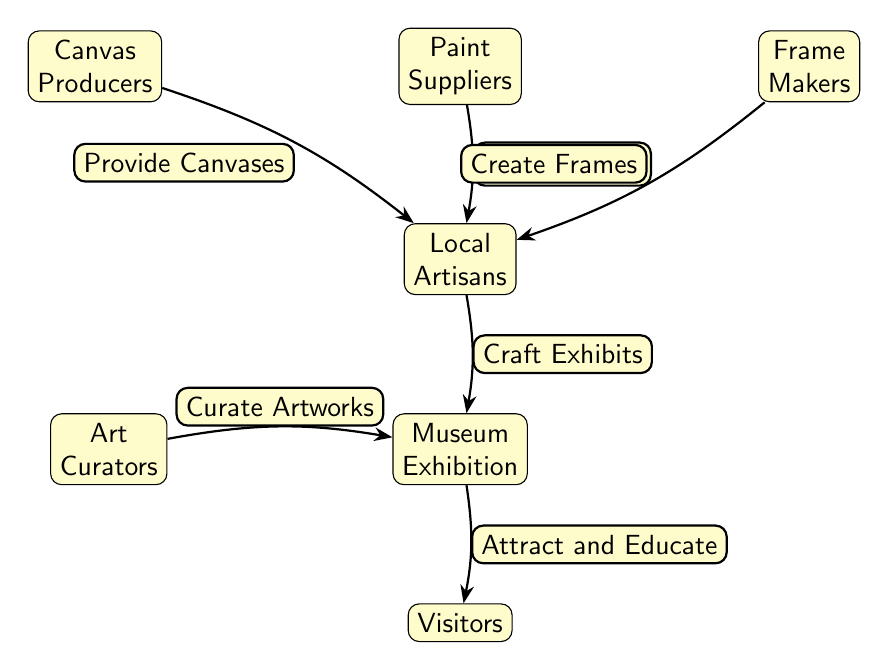What is the first node in the diagram? The first node in the diagram is labeled "Canvas Producers". It is positioned at the top-left corner of the diagram, signifying it as the starting element in the food chain.
Answer: Canvas Producers How many nodes are present in the diagram? There are a total of six nodes in the diagram: Canvas Producers, Paint Suppliers, Frame Makers, Local Artisans, Art Curators, Museum Exhibition, and Visitors. Counting these gives us a total of six distinct nodes.
Answer: 6 What does the Local Artisans node receive from the Paint Suppliers node? The Local Artisans node receives "Supply Paints" from the Paint Suppliers node. This is indicated by the directed edge between the two nodes showing the flow of supplies to the artisans.
Answer: Supply Paints Which node is directly below the Local Artisans node? The node directly below the Local Artisans node is labeled "Museum Exhibition." This is determined by looking at the vertical arrangement of the nodes in the diagram.
Answer: Museum Exhibition What relationships do the Art Curators have with the Museum Exhibition? The Art Curators are connected to the Museum Exhibition with the relationship "Curate Artworks." This indicates their role in organizing and selecting artworks for the exhibition.
Answer: Curate Artworks Which node attracts and educates the Visitors? The Museum Exhibition node attracts and educates the Visitors. This relationship is indicated by the edge leading from the exhibition to the visitors, signifying its purpose.
Answer: Museum Exhibition What is the last node in the diagram? The last node in the diagram is labeled "Visitors." It symbolizes the endpoint of the food chain, where the result of all previous nodes culminates in the viewing experience for visitors.
Answer: Visitors Explain the flow of materials from Canvas Producers to Museum Exhibition. The flow starts with the Canvas Producers who provide canvases to the Local Artisans. Simultaneously, the Paint Suppliers supply paints, and the Frame Makers create frames for the artisans. The Local Artisans then craft exhibits using these materials, while Art Curators facilitate the organization of art for the Museum Exhibition. Finally, all these efforts are directed towards the Museum Exhibition, showcasing the artworks.
Answer: Canvas Producers → Local Artisans → Museum Exhibition What do the Local Artisans do with the materials received from the first three nodes? The Local Artisans craft exhibits using the canvases, paints, and frames provided by the Canvas Producers, Paint Suppliers, and Frame Makers. This activity transforms raw materials into finished art exhibits for display.
Answer: Craft Exhibits 